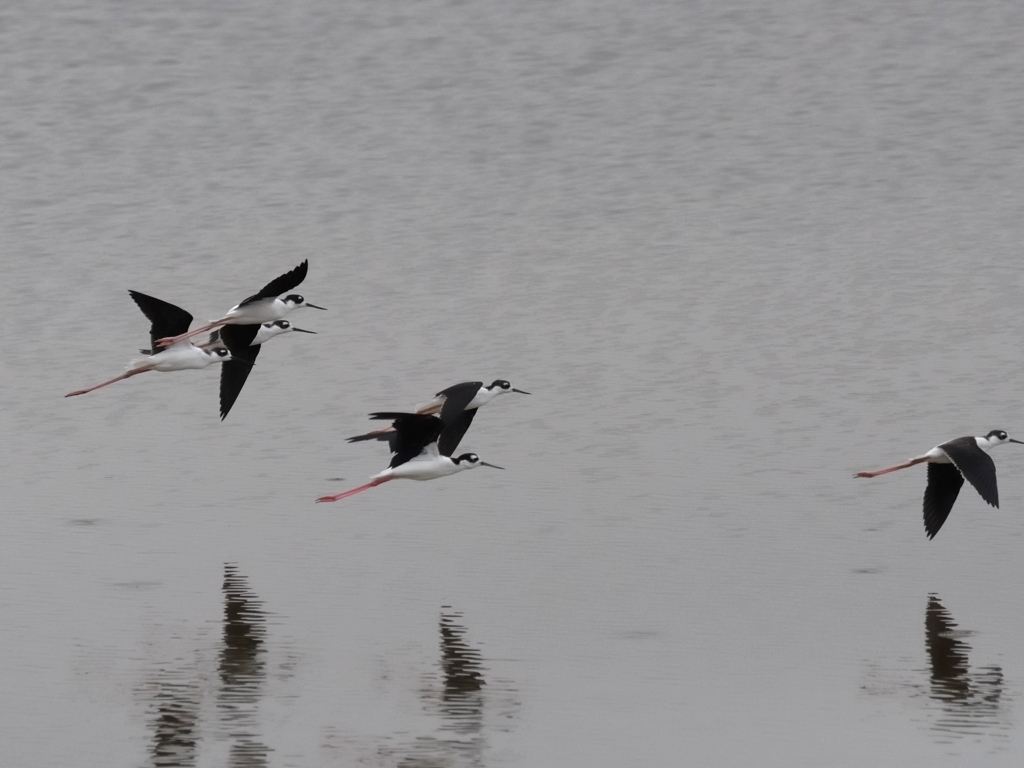What time of day do you think this photo was taken, and why might that be significant? The overcast sky and the soft lighting suggests that this photo could have been taken in the early morning or late afternoon. These times are often when birds are more active, typically hunting for food, which makes it an ideal window for bird photography to capture such dynamic behavior. 